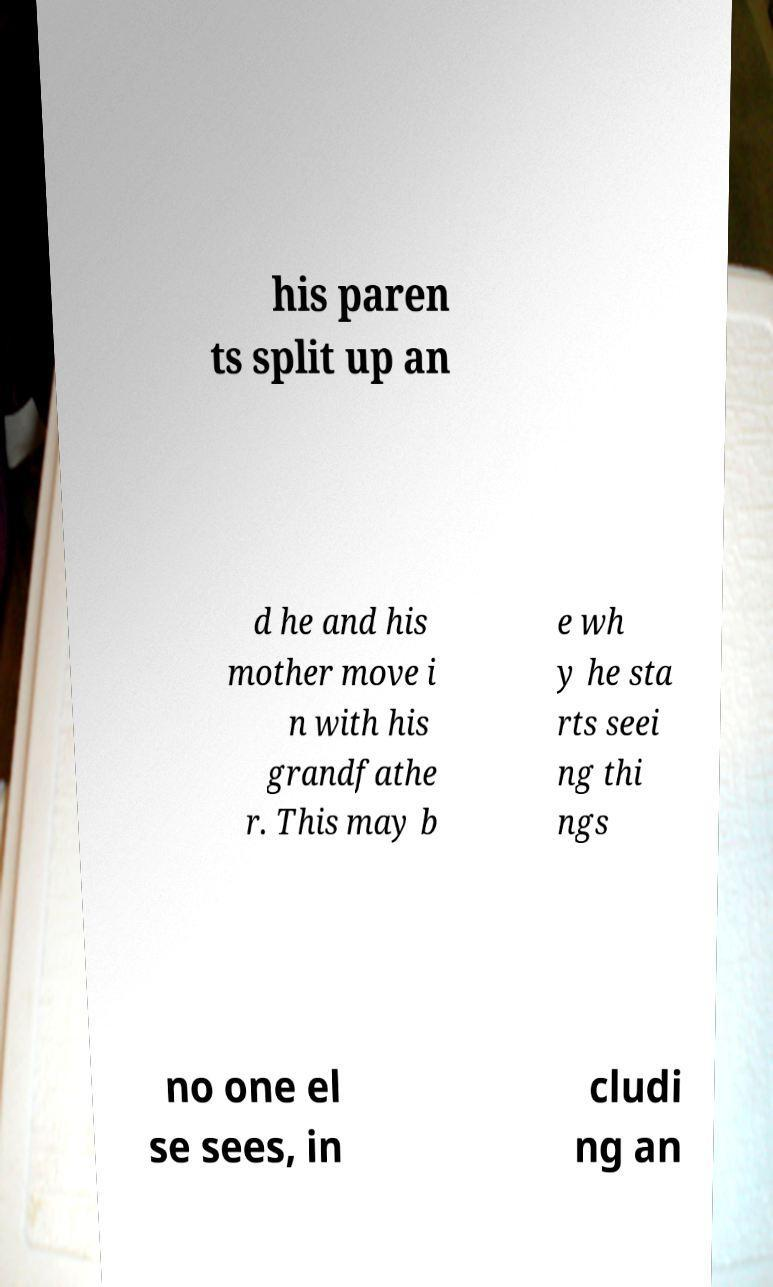Can you accurately transcribe the text from the provided image for me? his paren ts split up an d he and his mother move i n with his grandfathe r. This may b e wh y he sta rts seei ng thi ngs no one el se sees, in cludi ng an 